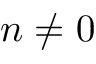<formula> <loc_0><loc_0><loc_500><loc_500>n \neq 0</formula> 